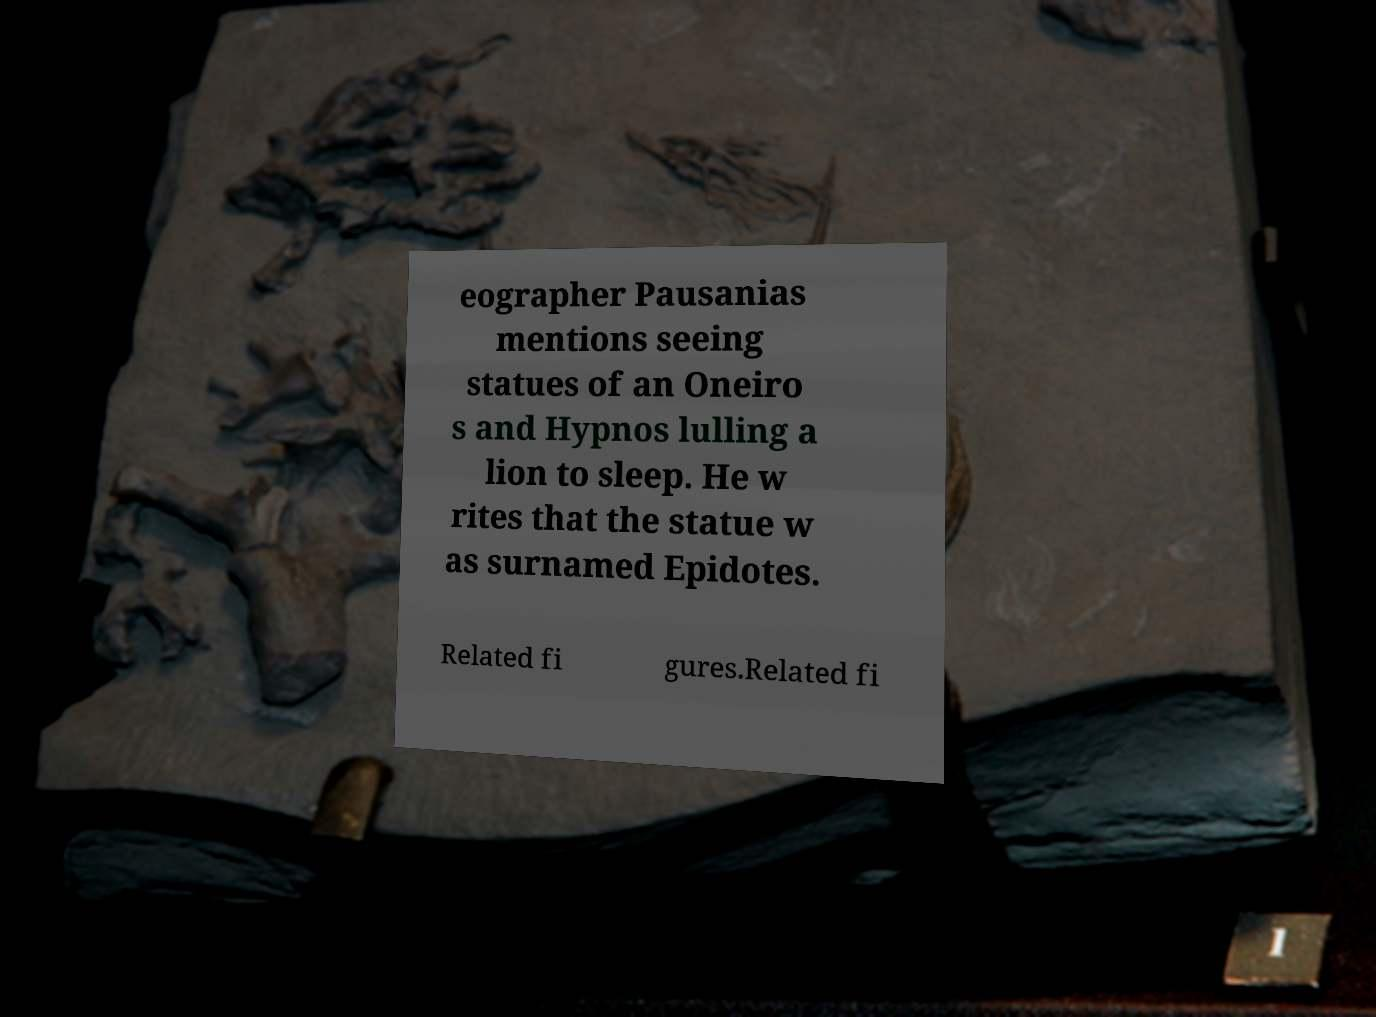Can you accurately transcribe the text from the provided image for me? eographer Pausanias mentions seeing statues of an Oneiro s and Hypnos lulling a lion to sleep. He w rites that the statue w as surnamed Epidotes. Related fi gures.Related fi 